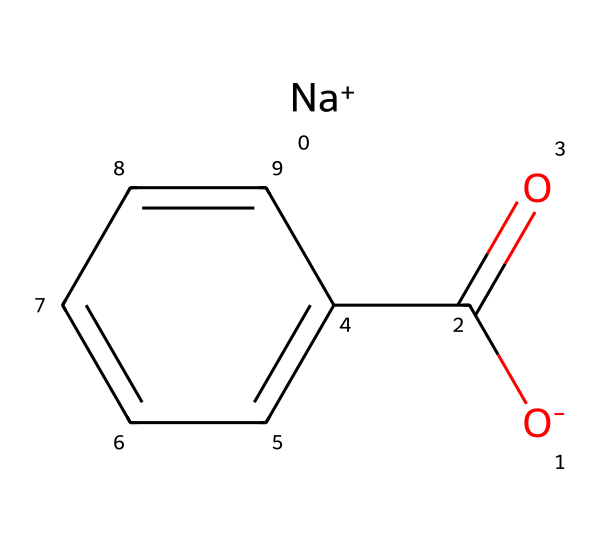What is the chemical name of this compound? The SMILES representation depicts sodium benzoate, which can be inferred from the presence of the benzoate structure (c1ccccc1) and the sodium ion ([Na+]).
Answer: sodium benzoate How many carbon atoms are present in the structure? In the SMILES, the "C(=O)" indicates one carbon atom in the carboxylate group, and "c1ccccc1" represents a benzene ring consisting of six carbon atoms, totaling to seven carbon atoms in the compound.
Answer: seven What type of bonding is primarily present in sodium benzoate? The structure shows covalent bonding, primarily between carbon and oxygen in the carboxylate group. The sodium ion is ionically bonded to the negatively charged carboxylate part of the molecule.
Answer: covalent and ionic What functional group is represented in this structure? The presence of "C(=O)" and the -O in the chemical represents a carboxylate functional group. This is characteristic of preservative chemical structures.
Answer: carboxylate How many hydrogen atoms are likely present in sodium benzoate? The complete structure would have five hydrogen atoms in the benzene ring, while the carboxylate component typically would lose one hydrogen in the ionized form, resulting in five hydrogens remaining.
Answer: five What makes sodium benzoate effective as a preservative? This compound's acidic nature allows it to inhibit the growth of mold and bacteria by lowering pH, particularly in acidic environments, thus extending the shelf life of products.
Answer: acidic nature 